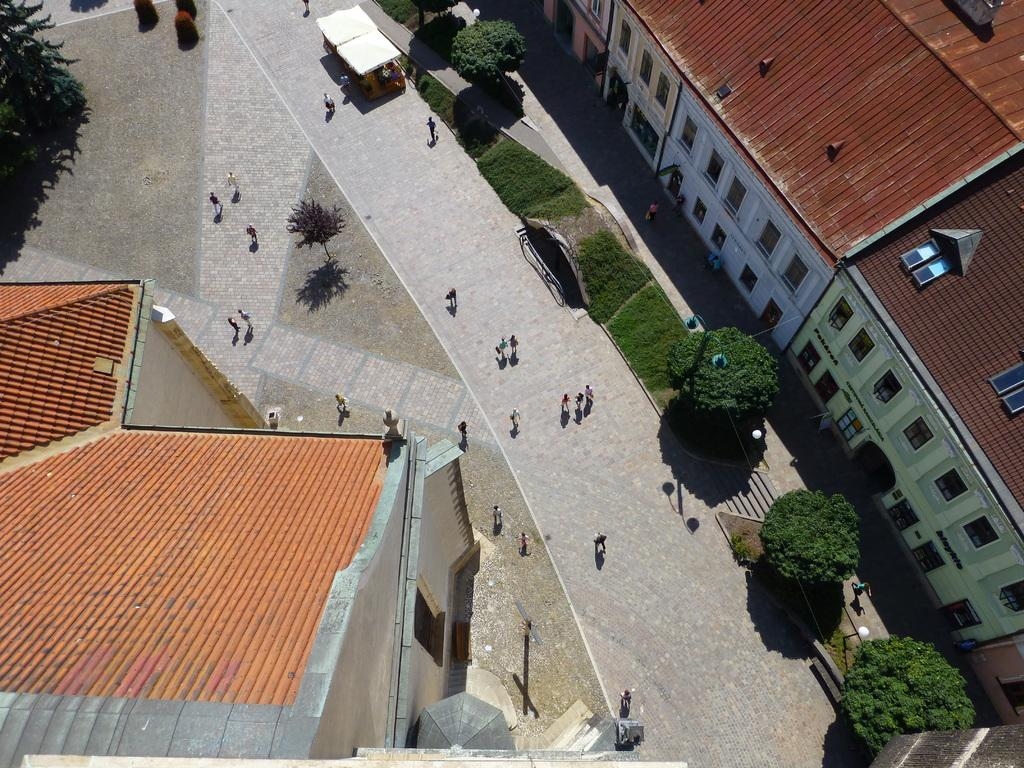What is located in the middle of the image? There are persons in the middle of the image. What type of vegetation can be seen on either side of the image? There are trees on either side of the image. What type of structures are present on either side of the image? There are buildings on either side of the image. What is the texture of the alley in the image? There is no alley present in the image; it features persons, trees, and buildings. 